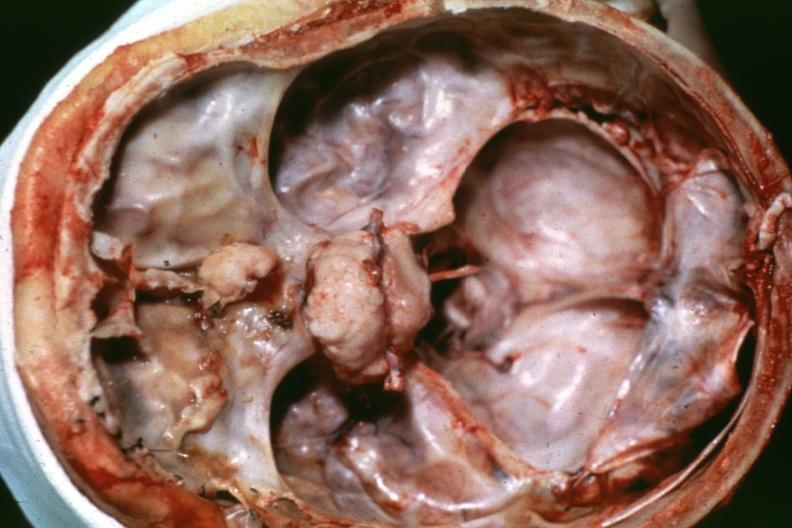s meningioma present?
Answer the question using a single word or phrase. Yes 